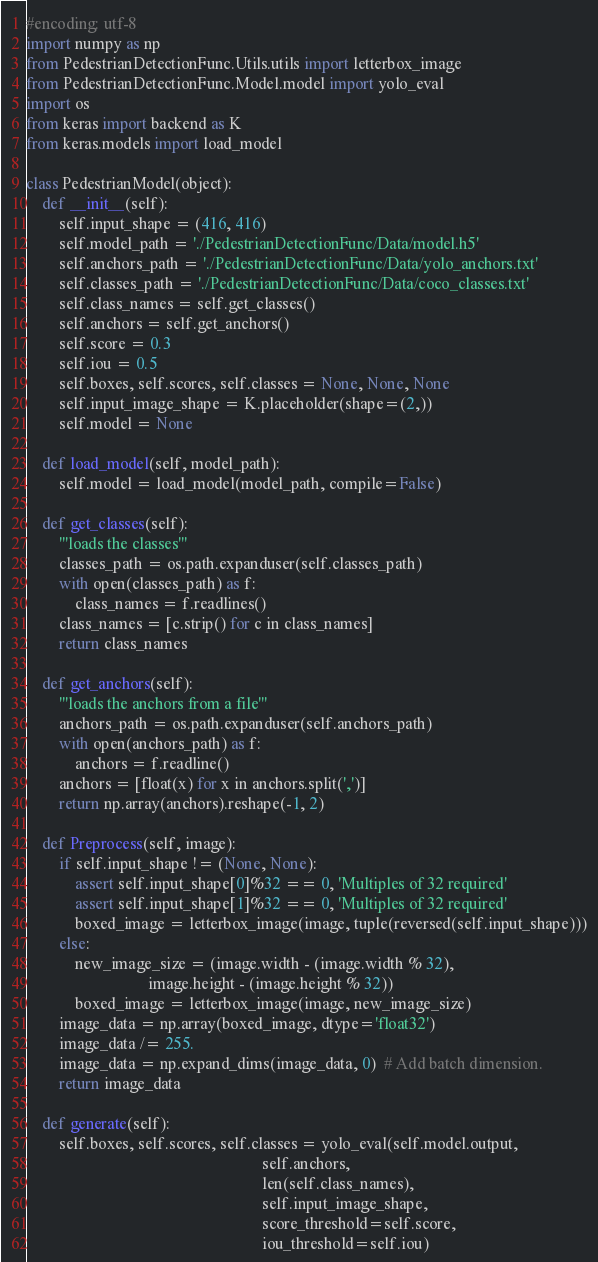<code> <loc_0><loc_0><loc_500><loc_500><_Python_>#encoding: utf-8
import numpy as np
from PedestrianDetectionFunc.Utils.utils import letterbox_image
from PedestrianDetectionFunc.Model.model import yolo_eval
import os
from keras import backend as K
from keras.models import load_model

class PedestrianModel(object):
    def __init__(self):
        self.input_shape = (416, 416)
        self.model_path = './PedestrianDetectionFunc/Data/model.h5'
        self.anchors_path = './PedestrianDetectionFunc/Data/yolo_anchors.txt'
        self.classes_path = './PedestrianDetectionFunc/Data/coco_classes.txt'
        self.class_names = self.get_classes()
        self.anchors = self.get_anchors()
        self.score = 0.3
        self.iou = 0.5
        self.boxes, self.scores, self.classes = None, None, None
        self.input_image_shape = K.placeholder(shape=(2,))
        self.model = None

    def load_model(self, model_path):
        self.model = load_model(model_path, compile=False)

    def get_classes(self):
        '''loads the classes'''
        classes_path = os.path.expanduser(self.classes_path)
        with open(classes_path) as f:
            class_names = f.readlines()
        class_names = [c.strip() for c in class_names]
        return class_names

    def get_anchors(self):
        '''loads the anchors from a file'''
        anchors_path = os.path.expanduser(self.anchors_path)
        with open(anchors_path) as f:
            anchors = f.readline()
        anchors = [float(x) for x in anchors.split(',')]
        return np.array(anchors).reshape(-1, 2)

    def Preprocess(self, image):
        if self.input_shape != (None, None):
            assert self.input_shape[0]%32 == 0, 'Multiples of 32 required'
            assert self.input_shape[1]%32 == 0, 'Multiples of 32 required'
            boxed_image = letterbox_image(image, tuple(reversed(self.input_shape)))
        else:
            new_image_size = (image.width - (image.width % 32),
                              image.height - (image.height % 32))
            boxed_image = letterbox_image(image, new_image_size)
        image_data = np.array(boxed_image, dtype='float32')
        image_data /= 255.
        image_data = np.expand_dims(image_data, 0)  # Add batch dimension.
        return image_data

    def generate(self):
        self.boxes, self.scores, self.classes = yolo_eval(self.model.output,
                                                          self.anchors,
                                                          len(self.class_names),
                                                          self.input_image_shape,
                                                          score_threshold=self.score,
                                                          iou_threshold=self.iou)










</code> 